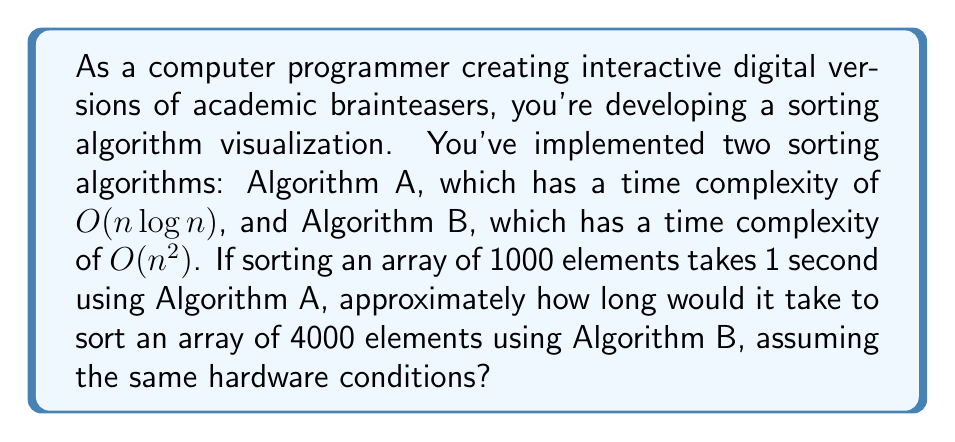What is the answer to this math problem? Let's approach this step-by-step:

1) First, we need to understand the time complexities:
   - Algorithm A: $O(n \log n)$
   - Algorithm B: $O(n^2)$

2) We're given that for Algorithm A:
   - $n = 1000$
   - Time = 1 second

3) Let's call the constant factor for Algorithm A as $k$. Then:
   $k * 1000 * \log(1000) = 1$ second

4) We can calculate $k$:
   $k = \frac{1}{1000 * \log(1000)} \approx 1.44 * 10^{-7}$

5) Now, for Algorithm B with $n = 4000$, the time will be:
   $Time_B = k * 4000^2$

6) But remember, this $k$ is for Algorithm A. Algorithm B has a different constant factor. Let's call it $c*k$ where $c$ is some multiplier.

7) So, the actual time for Algorithm B will be:
   $Time_B = c * k * 4000^2$

8) We don't know $c$, but we can compare the ratio of the times:

   $\frac{Time_B}{Time_A} = \frac{c * k * 4000^2}{k * 1000 * \log(1000)}$

9) Simplifying:
   $\frac{Time_B}{Time_A} = c * \frac{4000^2}{1000 * \log(1000)} \approx c * 482.8$

10) Even if $c = 1$ (which is a very optimistic assumption), Algorithm B would take about 483 times longer than Algorithm A for these input sizes.

Therefore, Algorithm B would take approximately 483 seconds or about 8 minutes to sort 4000 elements, assuming the same hardware conditions and that the constant factors are similar.
Answer: Approximately 483 seconds or 8 minutes 